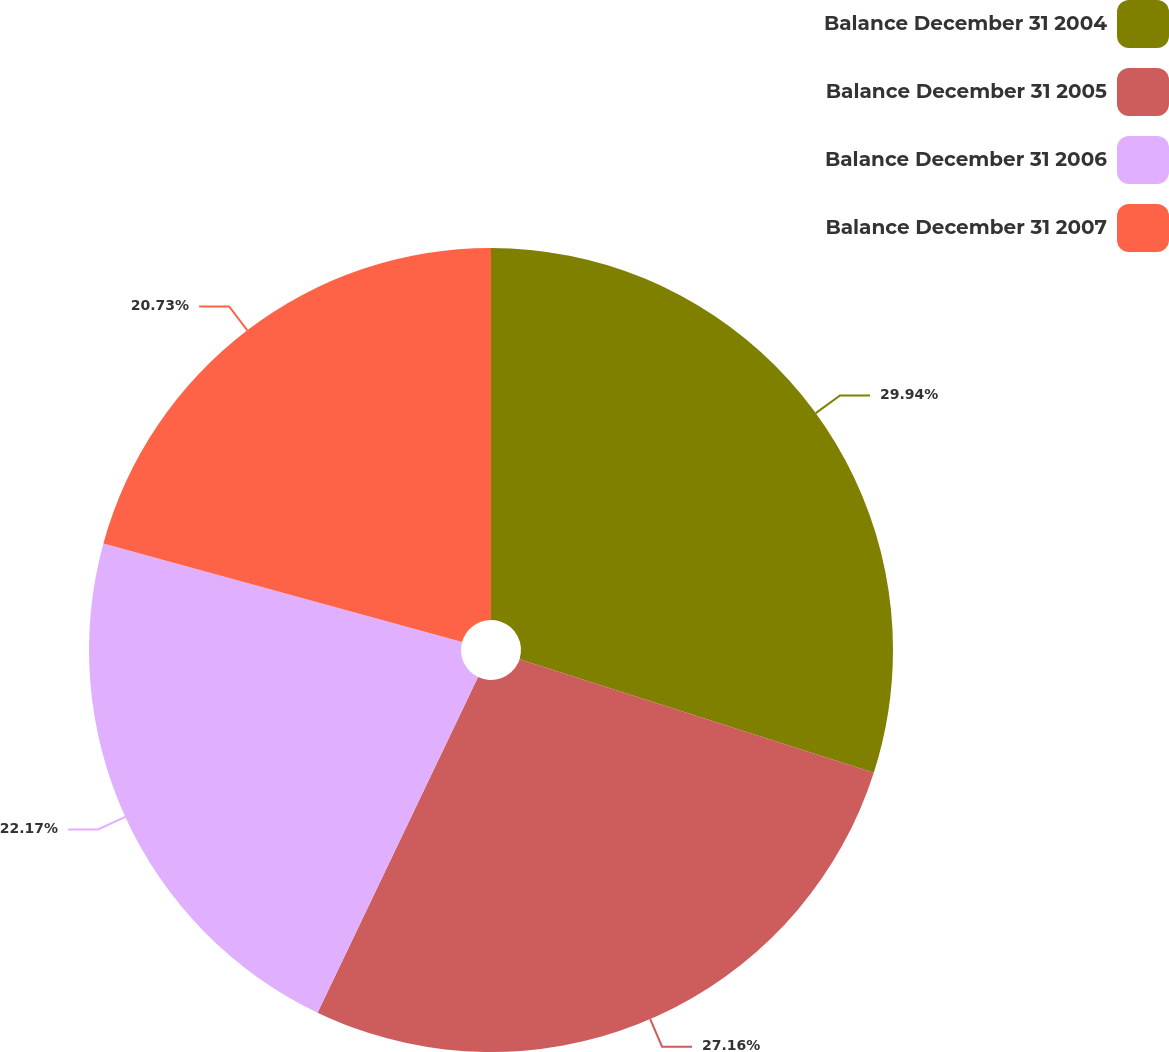<chart> <loc_0><loc_0><loc_500><loc_500><pie_chart><fcel>Balance December 31 2004<fcel>Balance December 31 2005<fcel>Balance December 31 2006<fcel>Balance December 31 2007<nl><fcel>29.94%<fcel>27.16%<fcel>22.17%<fcel>20.73%<nl></chart> 